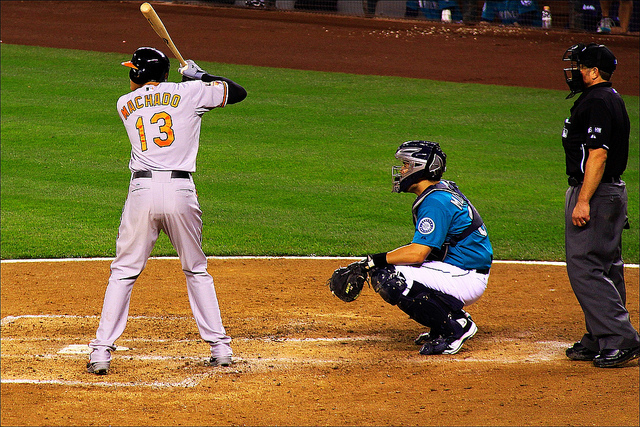Identify the text displayed in this image. MACHADO 13 